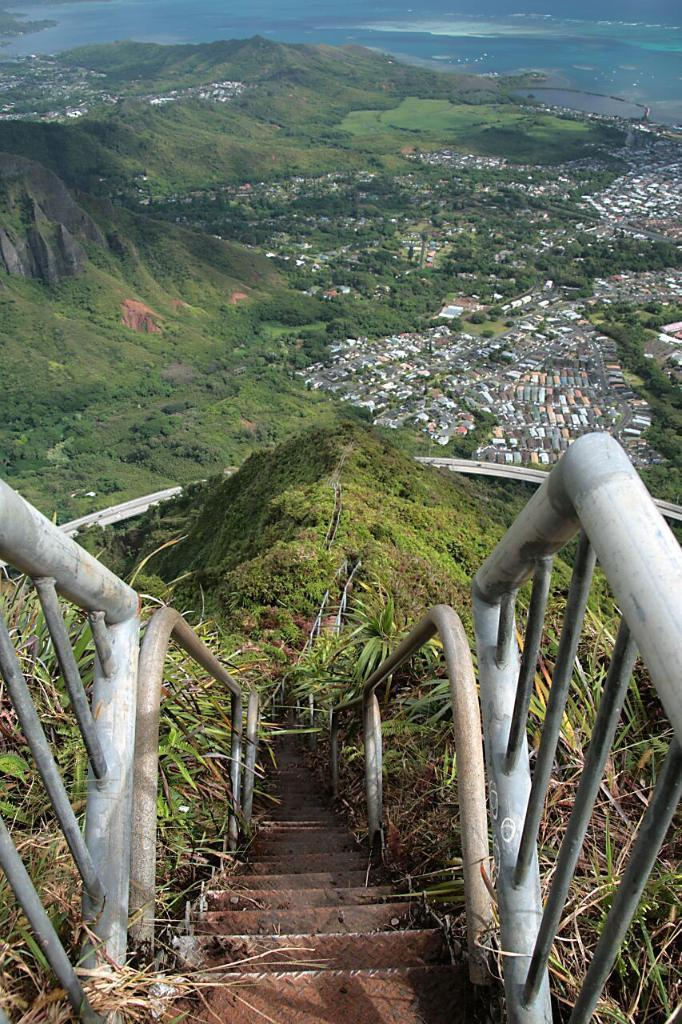What type of living organisms can be seen in the image? Plants can be seen in the image. What are the rods used for in the image? The purpose of the rods is not clear from the image. What architectural feature is present in the image? There are stairs in the image. What natural features can be seen in the background of the image? Mountains, a sea, trees, and houses can be seen in the background of the image. What book is the beetle reading in the image? There is no book or beetle present in the image. How many lights can be seen illuminating the scene in the image? There are no lights visible in the image. 